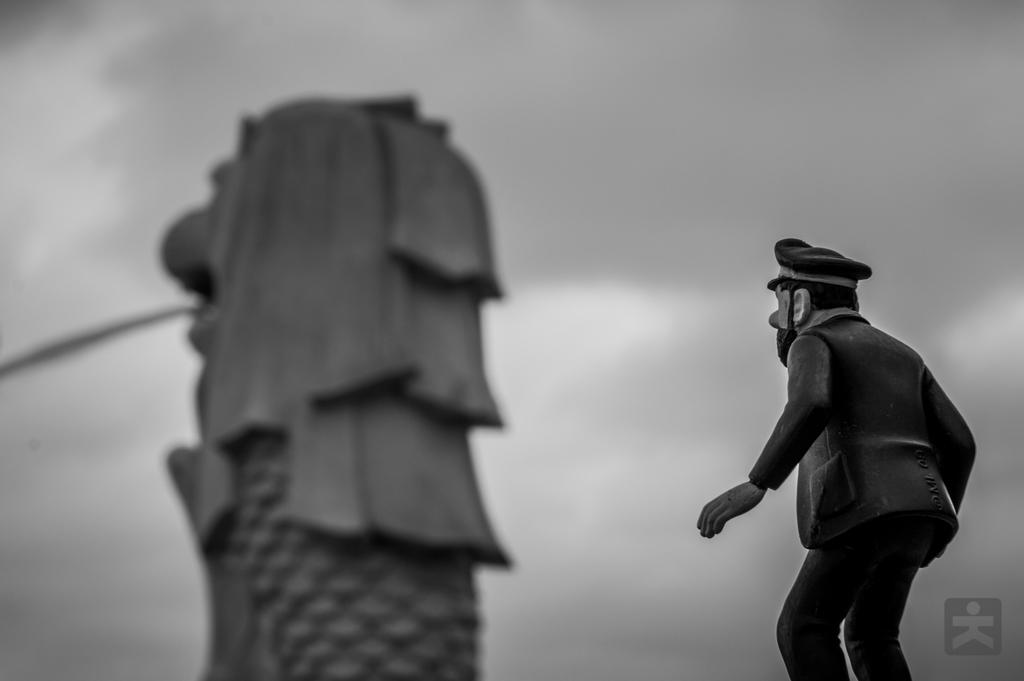What is the color scheme of the image? The image is black and white. What is the main subject in the image? There is a statue in the image. Are there any other objects or items in the image besides the statue? Yes, there is a toy in the image. What type of government is depicted in the image? There is no depiction of a government in the image; it features a statue and a toy in a black and white setting. Is there a coat visible on the statue in the image? There is no coat visible on the statue in the image; the statue and the toy are the main subjects in the image. 